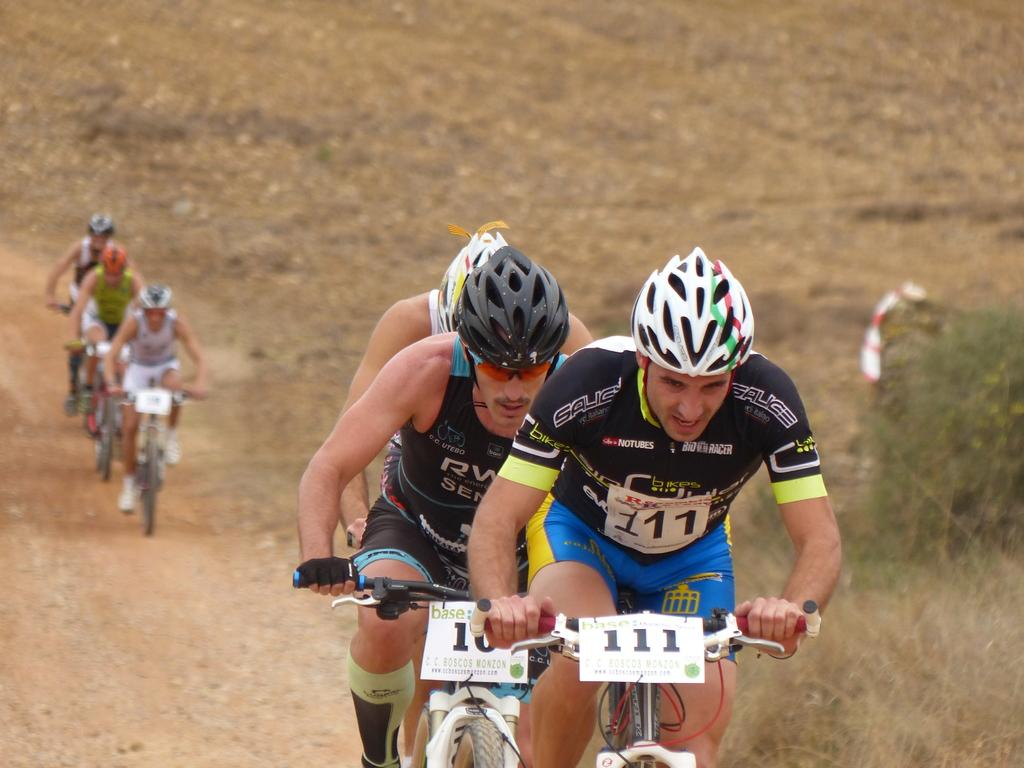What are the men in the image doing? The men in the image are sitting on bicycles. What can be seen beneath the men and bicycles? The ground is visible in the image. What type of vegetation is present in the image? There is grass in the image. What type of crate can be seen being carried by the men in the image? There is no crate present in the image; the men are sitting on bicycles. What type of chalk is being used to draw on the grass in the image? There is no chalk or drawing present in the image; it only features men sitting on bicycles and grass. 